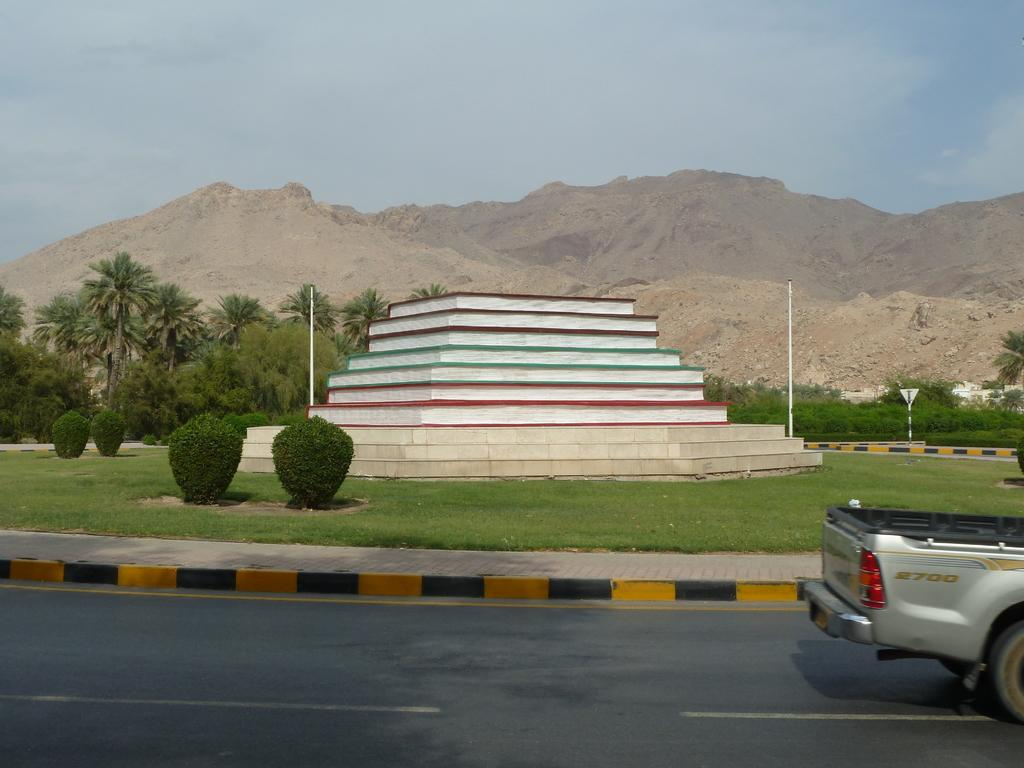Provide a one-sentence caption for the provided image. A pickup truck with 2700 on its side is partially visible in front of a pubic art piece. 